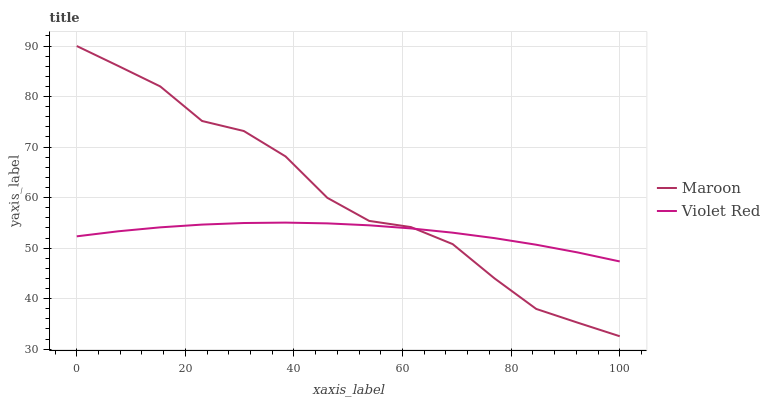Does Maroon have the minimum area under the curve?
Answer yes or no. No. Is Maroon the smoothest?
Answer yes or no. No. 